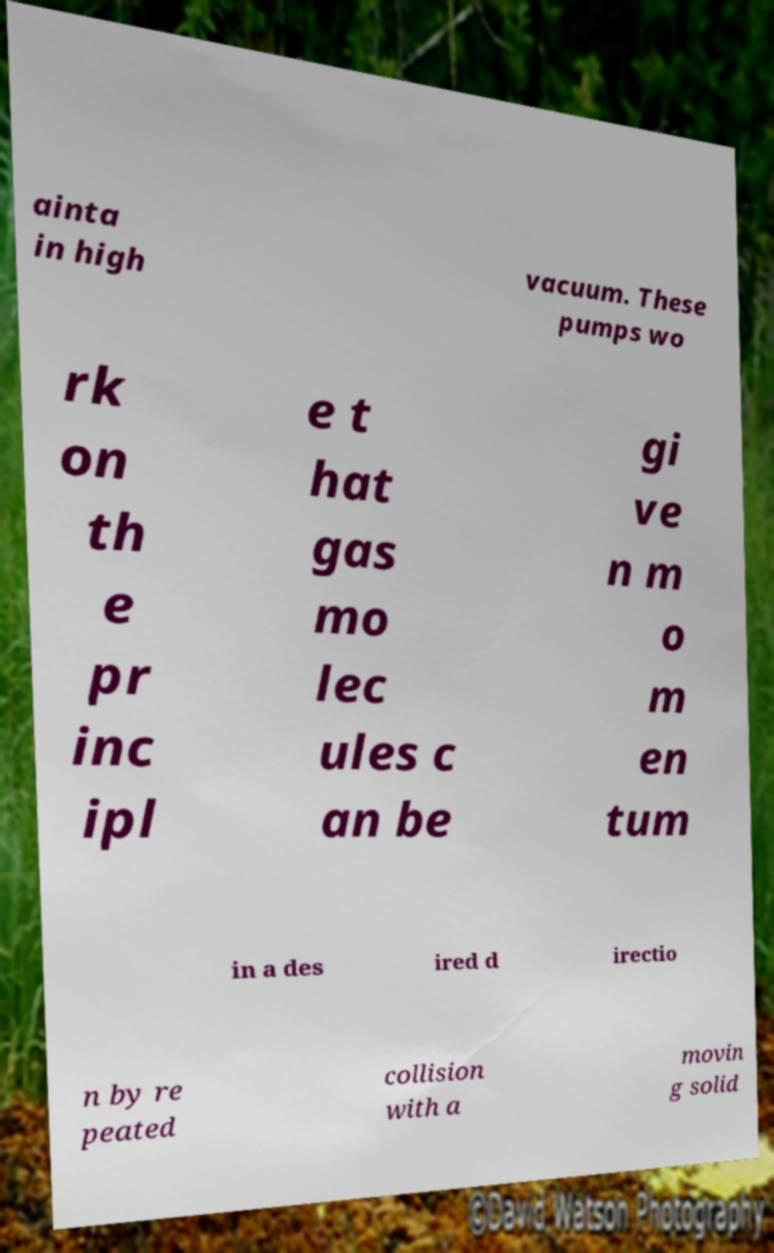Can you read and provide the text displayed in the image?This photo seems to have some interesting text. Can you extract and type it out for me? ainta in high vacuum. These pumps wo rk on th e pr inc ipl e t hat gas mo lec ules c an be gi ve n m o m en tum in a des ired d irectio n by re peated collision with a movin g solid 